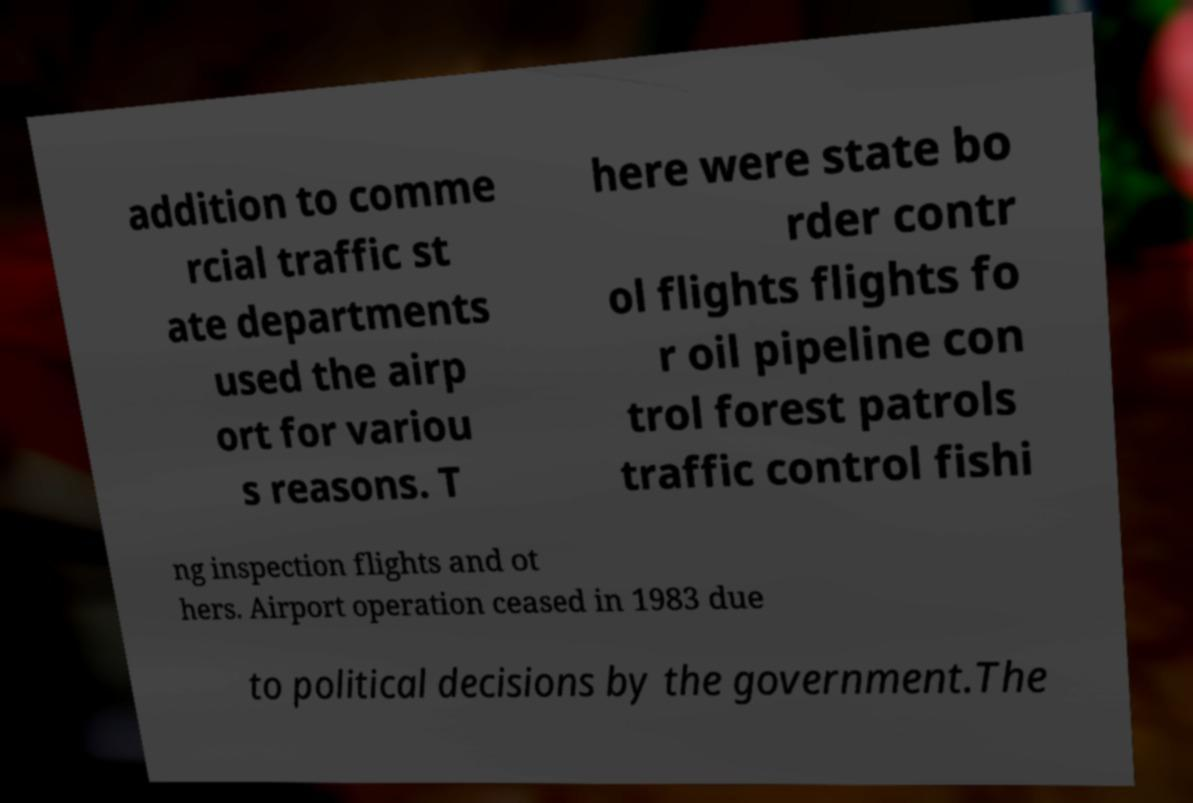For documentation purposes, I need the text within this image transcribed. Could you provide that? addition to comme rcial traffic st ate departments used the airp ort for variou s reasons. T here were state bo rder contr ol flights flights fo r oil pipeline con trol forest patrols traffic control fishi ng inspection flights and ot hers. Airport operation ceased in 1983 due to political decisions by the government.The 